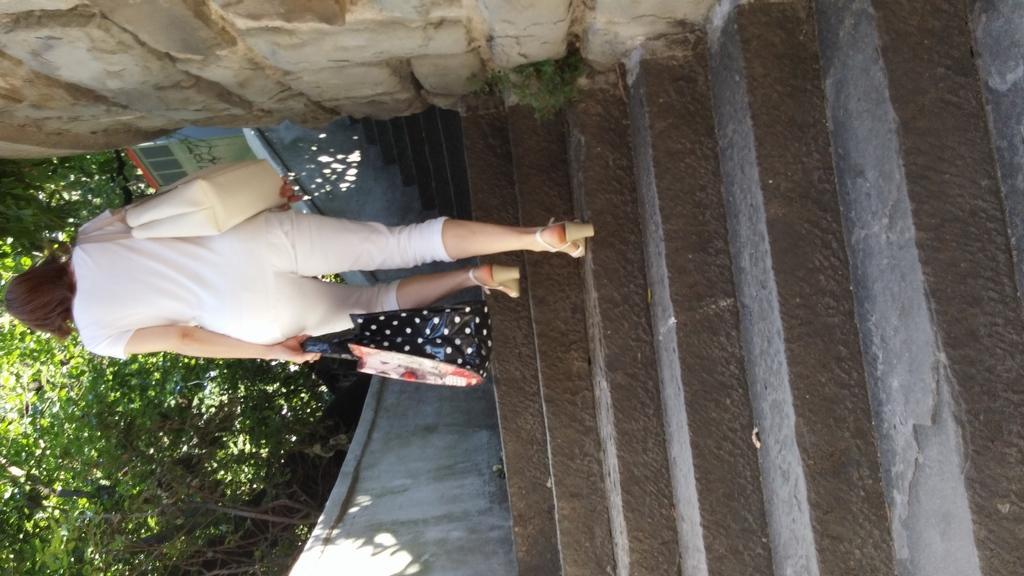How would you summarize this image in a sentence or two? In this picture we can see a woman walking and in the background we can see a wall,trees. 